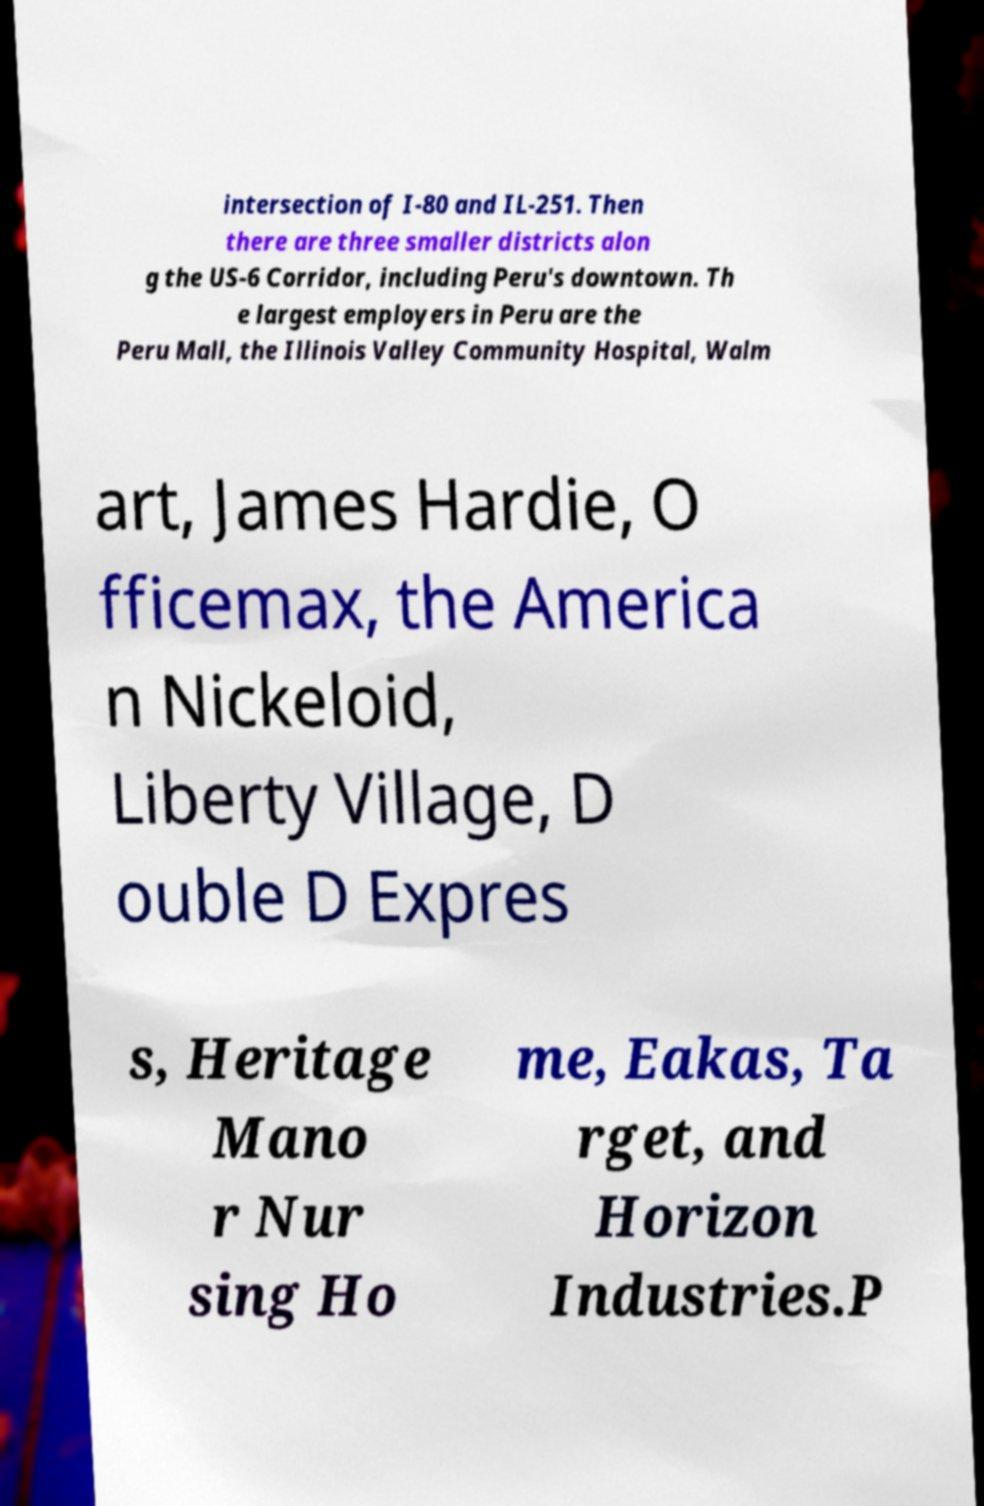Can you read and provide the text displayed in the image?This photo seems to have some interesting text. Can you extract and type it out for me? intersection of I-80 and IL-251. Then there are three smaller districts alon g the US-6 Corridor, including Peru's downtown. Th e largest employers in Peru are the Peru Mall, the Illinois Valley Community Hospital, Walm art, James Hardie, O fficemax, the America n Nickeloid, Liberty Village, D ouble D Expres s, Heritage Mano r Nur sing Ho me, Eakas, Ta rget, and Horizon Industries.P 